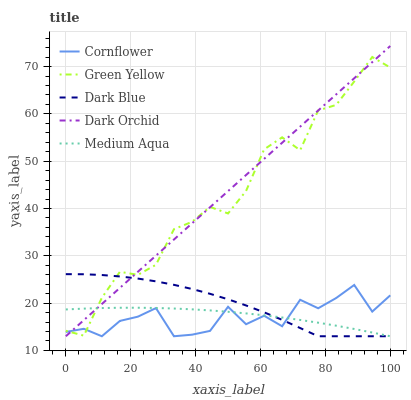Does Cornflower have the minimum area under the curve?
Answer yes or no. Yes. Does Dark Orchid have the maximum area under the curve?
Answer yes or no. Yes. Does Green Yellow have the minimum area under the curve?
Answer yes or no. No. Does Green Yellow have the maximum area under the curve?
Answer yes or no. No. Is Dark Orchid the smoothest?
Answer yes or no. Yes. Is Green Yellow the roughest?
Answer yes or no. Yes. Is Medium Aqua the smoothest?
Answer yes or no. No. Is Medium Aqua the roughest?
Answer yes or no. No. Does Cornflower have the lowest value?
Answer yes or no. Yes. Does Green Yellow have the lowest value?
Answer yes or no. No. Does Dark Orchid have the highest value?
Answer yes or no. Yes. Does Green Yellow have the highest value?
Answer yes or no. No. Does Dark Blue intersect Medium Aqua?
Answer yes or no. Yes. Is Dark Blue less than Medium Aqua?
Answer yes or no. No. Is Dark Blue greater than Medium Aqua?
Answer yes or no. No. 